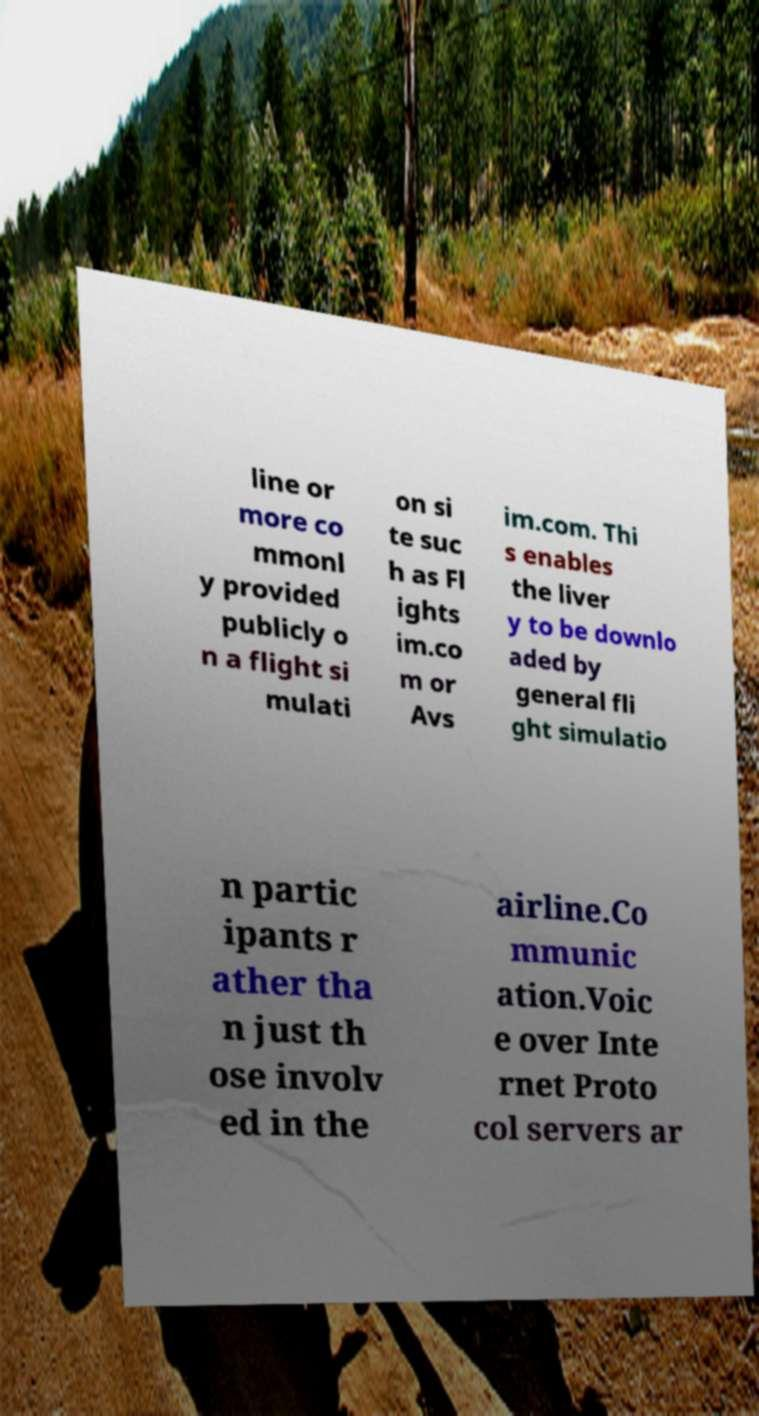Could you assist in decoding the text presented in this image and type it out clearly? line or more co mmonl y provided publicly o n a flight si mulati on si te suc h as Fl ights im.co m or Avs im.com. Thi s enables the liver y to be downlo aded by general fli ght simulatio n partic ipants r ather tha n just th ose involv ed in the airline.Co mmunic ation.Voic e over Inte rnet Proto col servers ar 